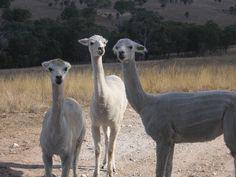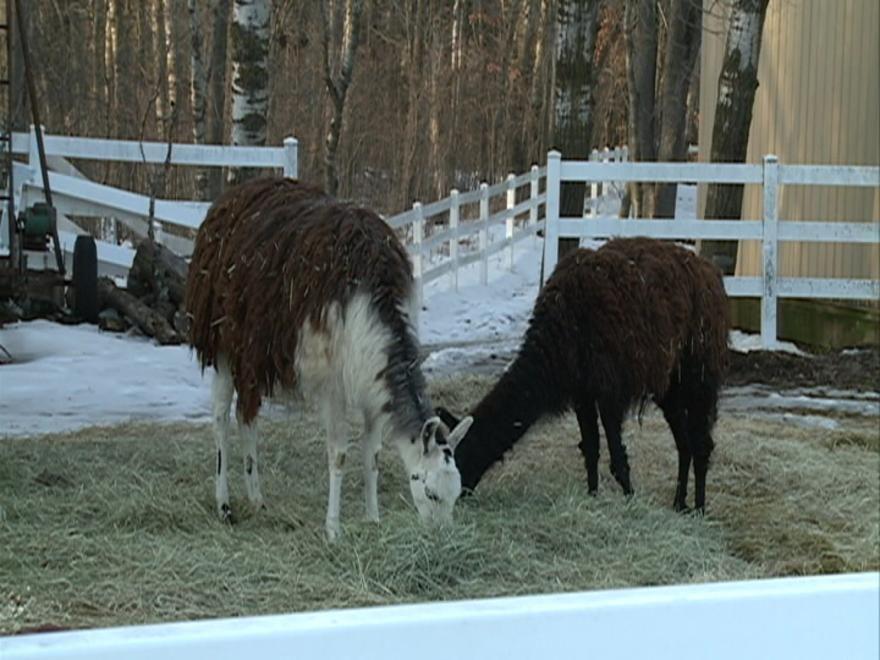The first image is the image on the left, the second image is the image on the right. Examine the images to the left and right. Is the description "All llama are standing with upright heads, and all llamas have their bodies turned rightward." accurate? Answer yes or no. No. The first image is the image on the left, the second image is the image on the right. Considering the images on both sides, is "There are at most four llamas in the image pair." valid? Answer yes or no. No. 